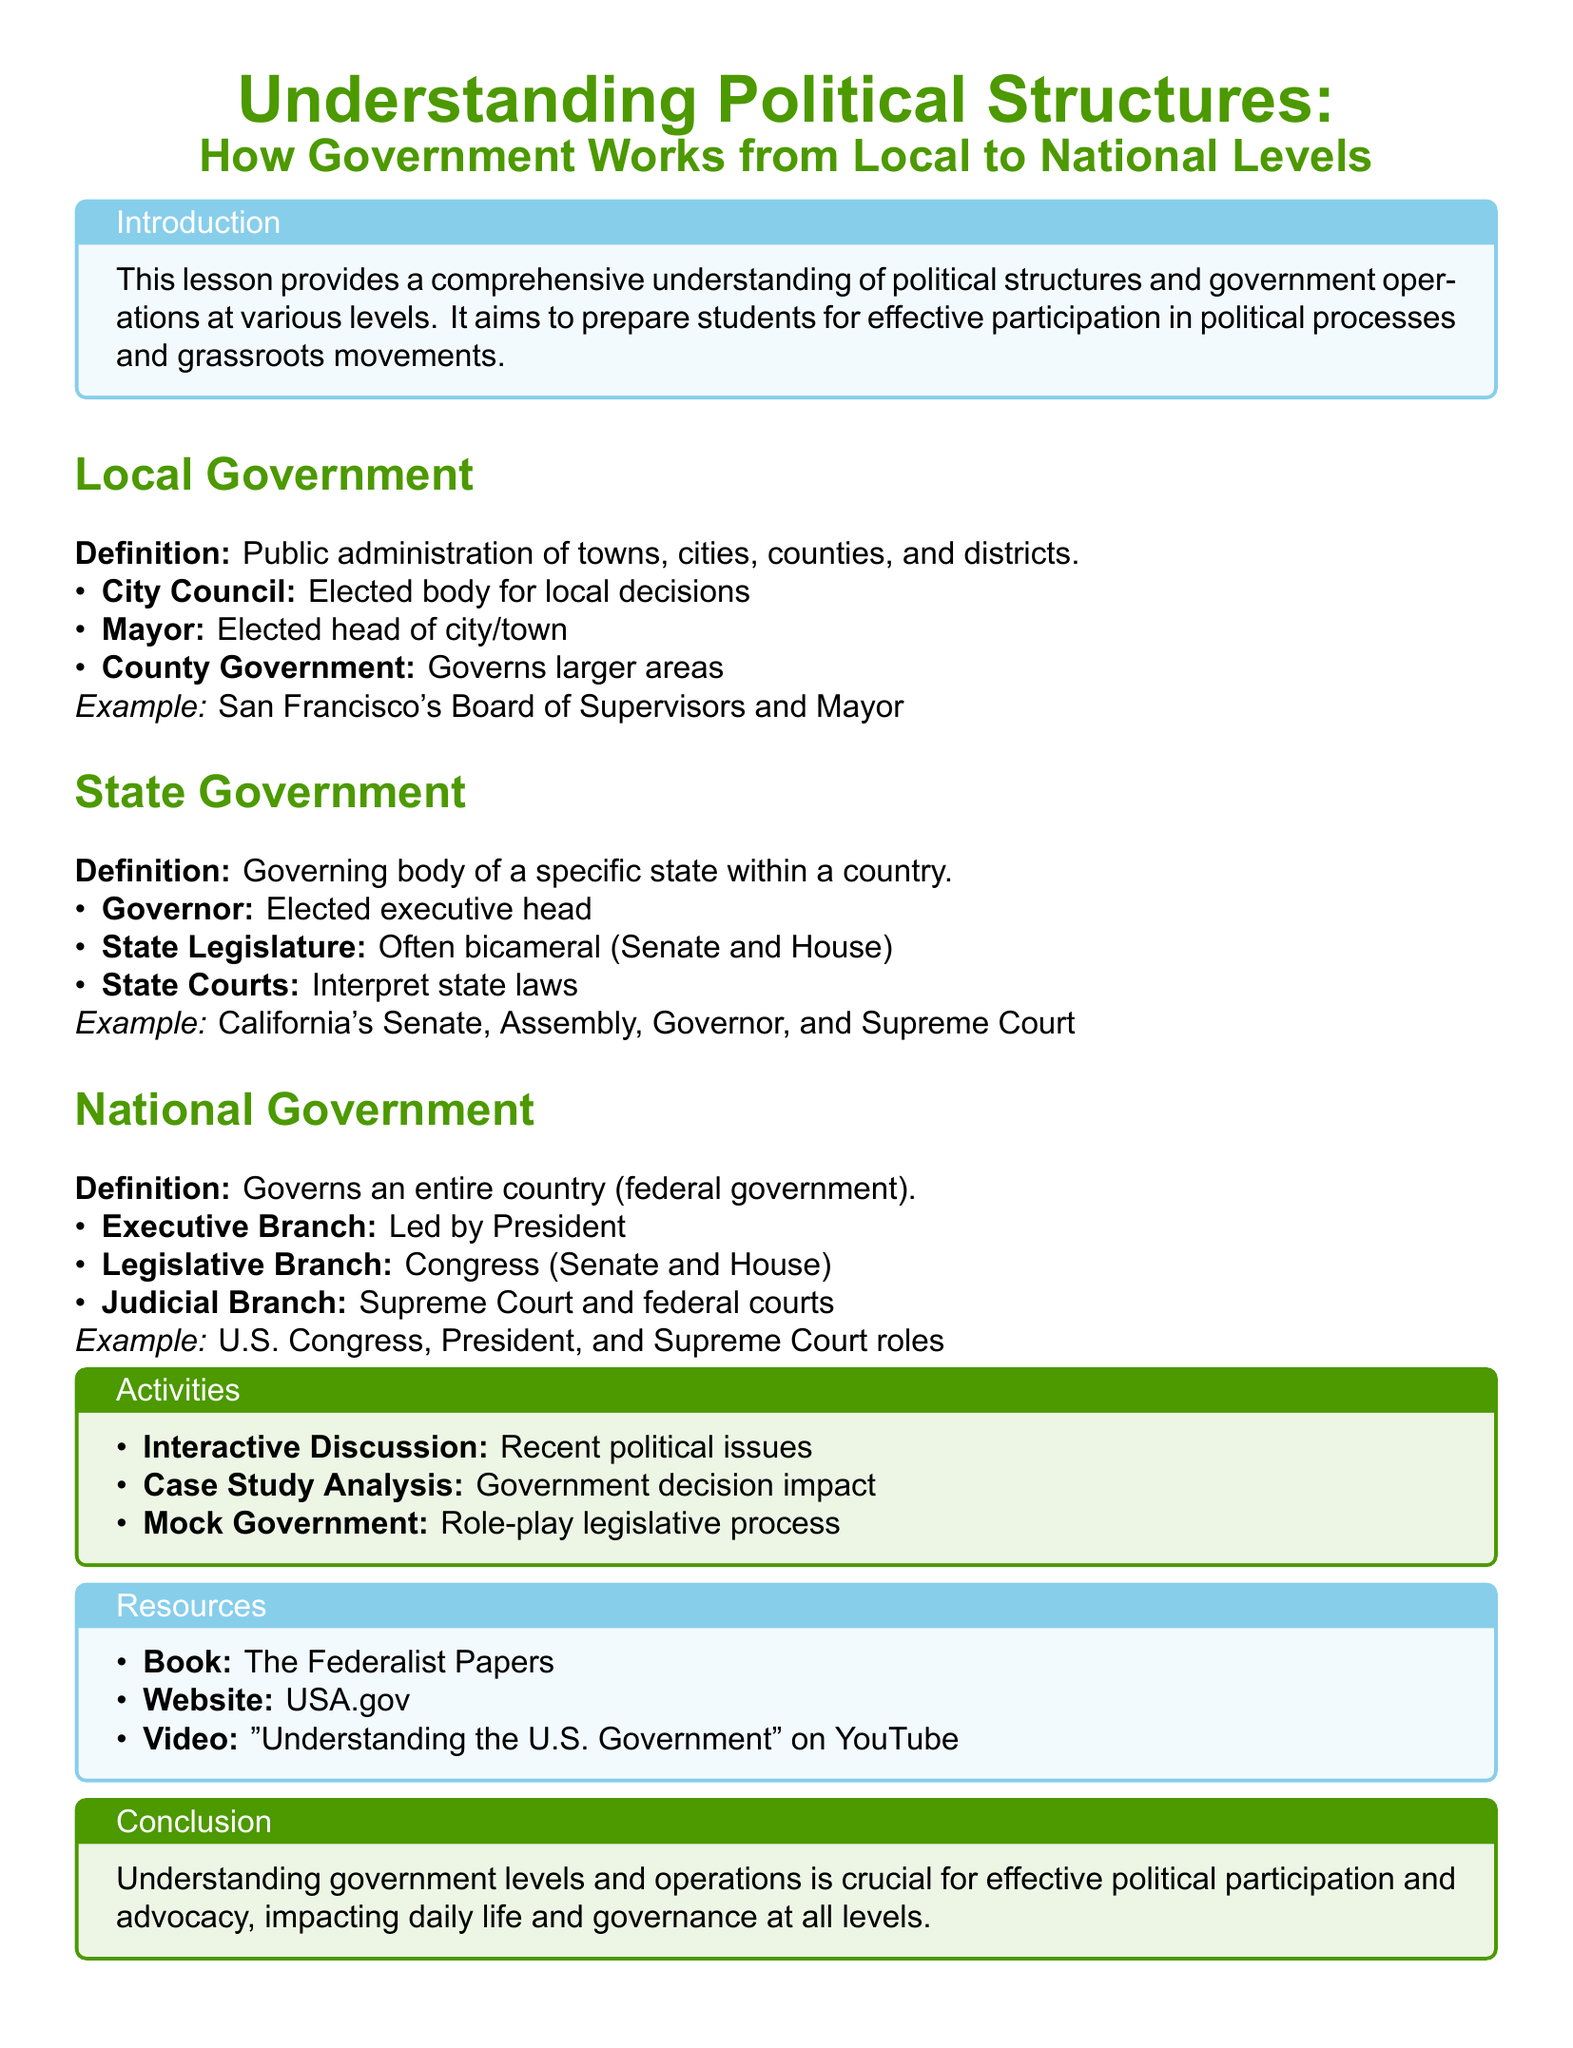What is the definition of Local Government? Local Government is defined as the public administration of towns, cities, counties, and districts.
Answer: Public administration of towns, cities, counties, and districts Who is the elected head of a city or town? The document specifies that the Mayor is the elected head of a city or town.
Answer: Mayor What is the governing body of a specific state called? The governing body of a specific state is referred to as State Government.
Answer: State Government Which two branches make up the Legislative Branch at the national level? The document states that the Legislative Branch, also known as Congress, is composed of the Senate and House.
Answer: Senate and House What is one activity included in the lesson plan? The lesson plan includes activities like an Interactive Discussion.
Answer: Interactive Discussion What are the three branches of the National Government? The document outlines that the three branches of the National Government are the Executive, Legislative, and Judicial branches.
Answer: Executive, Legislative, and Judicial What is an example of a local government in the document? The document specifies San Francisco's Board of Supervisors and Mayor as an example of local government.
Answer: San Francisco's Board of Supervisors and Mayor What is the resource type mentioned alongside "The Federalist Papers"? The document mentions a website, USA.gov, as a resource.
Answer: Website What is the primary goal of the lesson provided in the document? The primary goal of the lesson is to prepare students for effective participation in political processes and grassroots movements.
Answer: Prepare students for effective participation in political processes and grassroots movements 